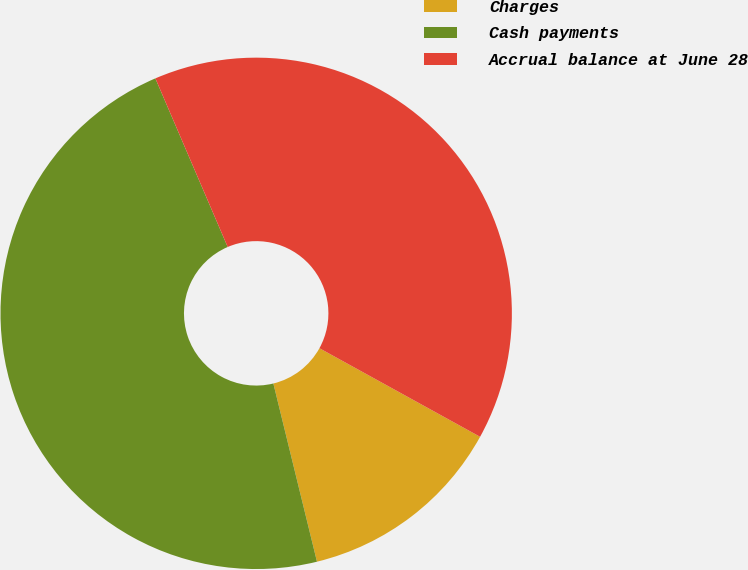Convert chart to OTSL. <chart><loc_0><loc_0><loc_500><loc_500><pie_chart><fcel>Charges<fcel>Cash payments<fcel>Accrual balance at June 28<nl><fcel>13.16%<fcel>47.37%<fcel>39.47%<nl></chart> 